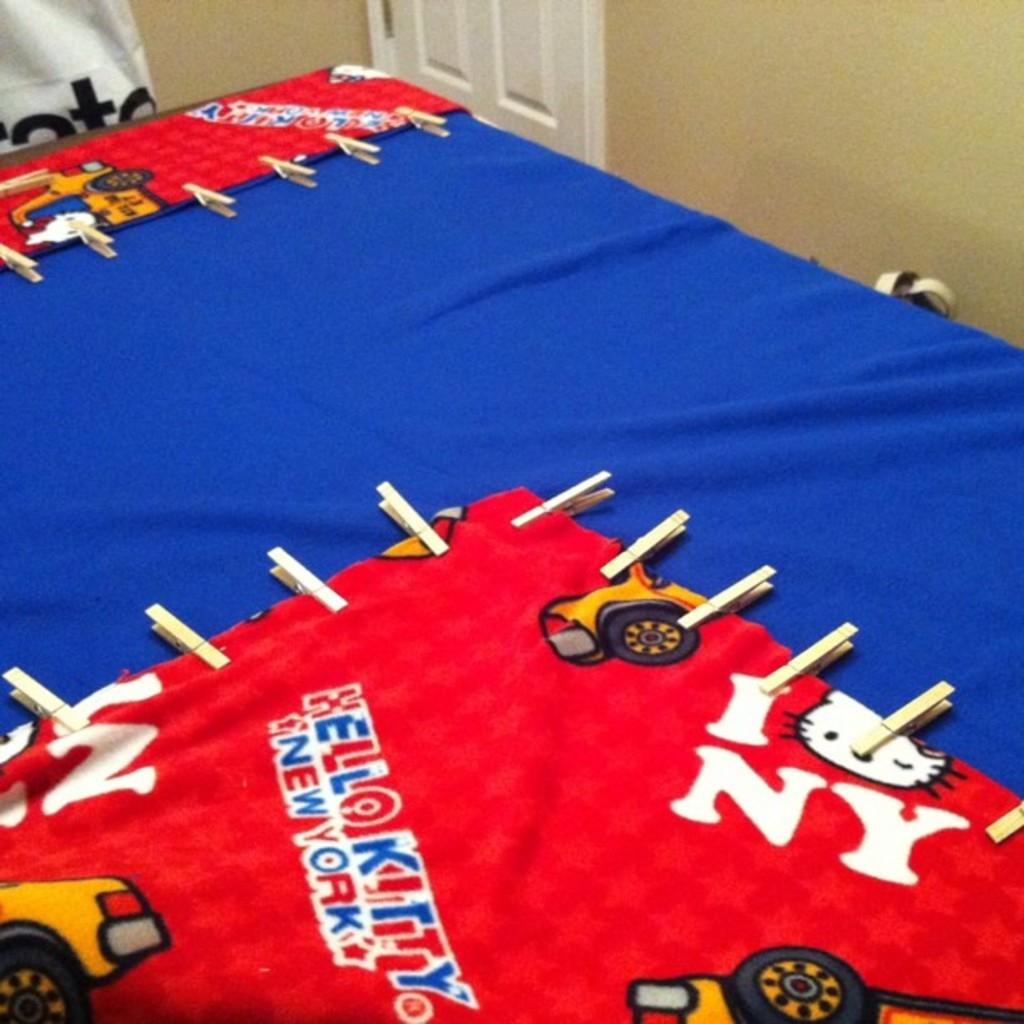What is the main piece of furniture in the image? There is a table in the image. What color is the cloth covering the table? The table is covered with a blue cloth. What can be seen in the background of the image? There is a white door in the background of the image. What color is the wall visible in the image? There is a cream-colored wall in the image. What type of shop can be seen in the image? There is no shop present in the image; it features a table with a blue cloth, cloth-covered table and a white door in the background. 